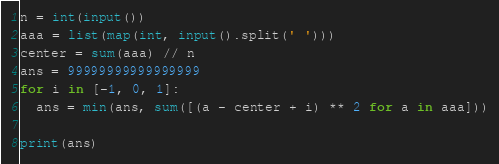Convert code to text. <code><loc_0><loc_0><loc_500><loc_500><_Python_>n = int(input())
aaa = list(map(int, input().split(' ')))
center = sum(aaa) // n
ans = 99999999999999999
for i in [-1, 0, 1]:
  ans = min(ans, sum([(a - center + i) ** 2 for a in aaa]))
  
print(ans)</code> 